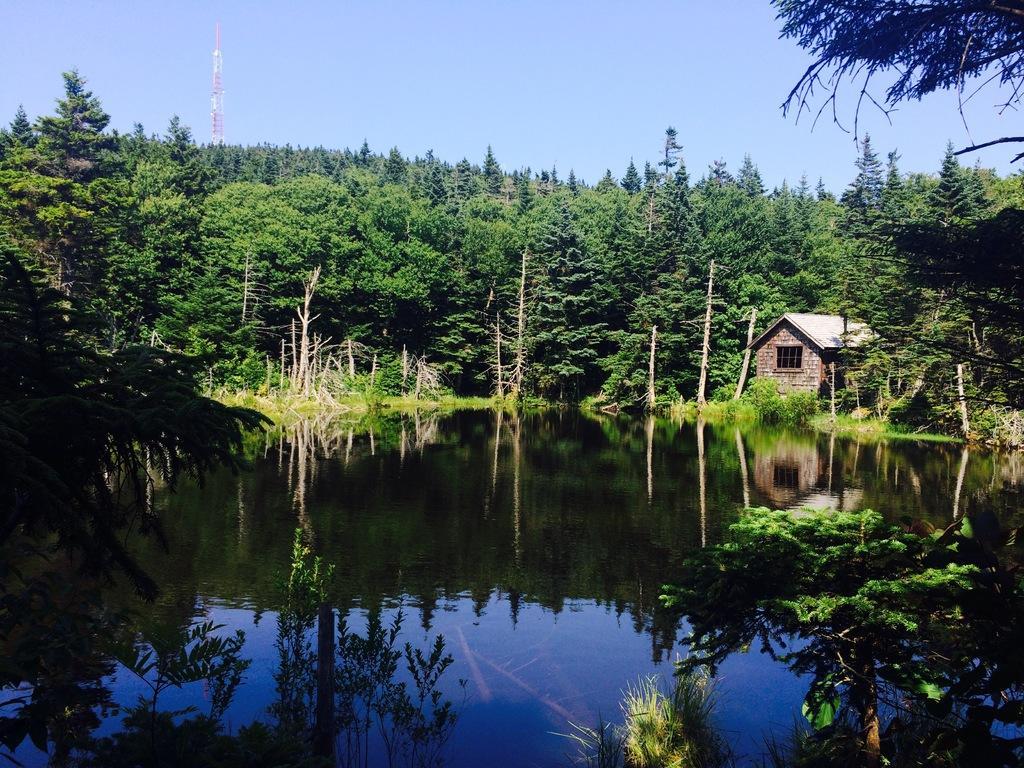Can you describe this image briefly? In this image we can see the water. Behind the water we can see a group of trees, plants and a house. At the top we can see the sky and a tower. In the water we can see the reflection of trees and the sky. 